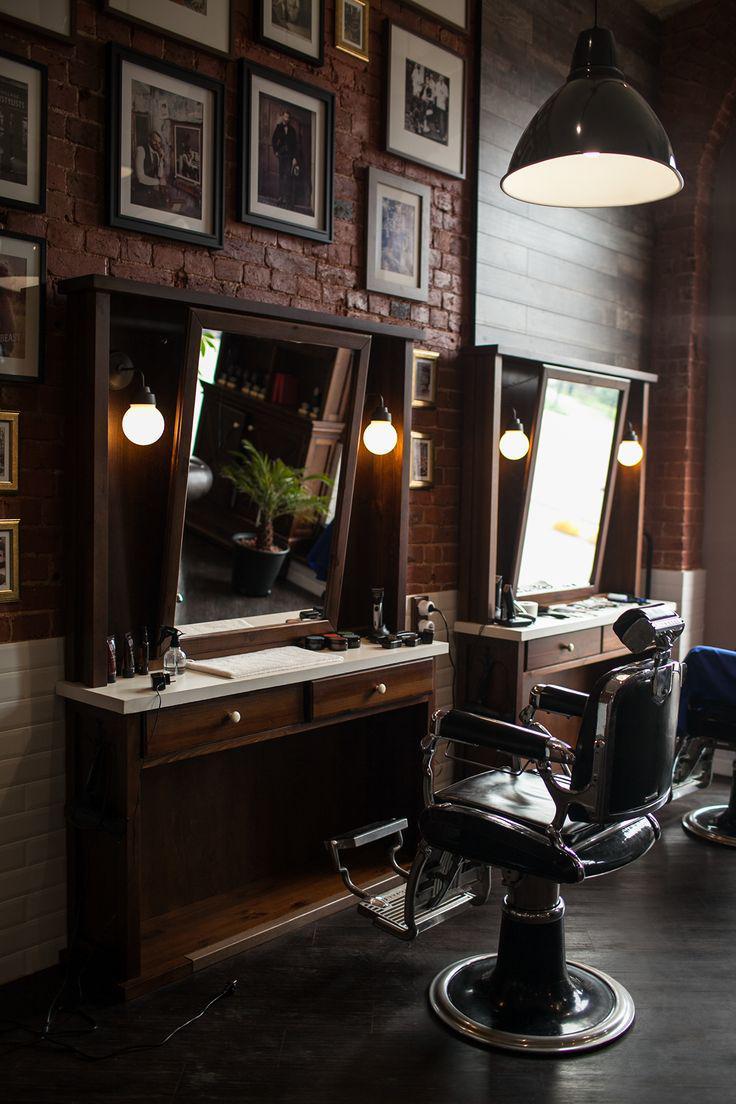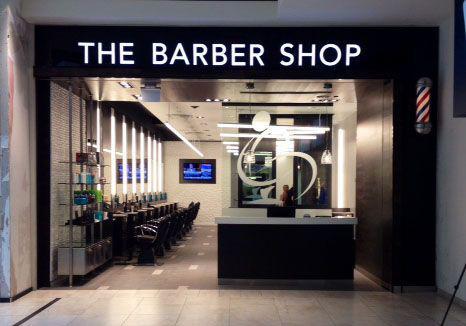The first image is the image on the left, the second image is the image on the right. Assess this claim about the two images: "One image is the interior of a barber shop and one image is the exterior of a barber shop". Correct or not? Answer yes or no. Yes. 